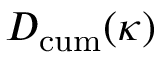<formula> <loc_0><loc_0><loc_500><loc_500>D _ { c u m } ( \kappa )</formula> 